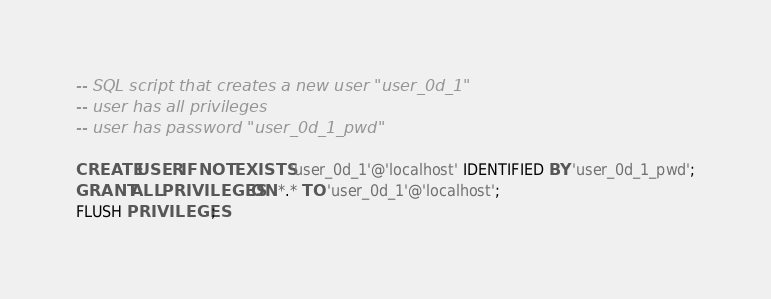<code> <loc_0><loc_0><loc_500><loc_500><_SQL_>-- SQL script that creates a new user "user_0d_1"
-- user has all privileges
-- user has password "user_0d_1_pwd"

CREATE USER IF NOT EXISTS 'user_0d_1'@'localhost' IDENTIFIED BY 'user_0d_1_pwd';
GRANT ALL PRIVILEGES ON *.* TO 'user_0d_1'@'localhost';
FLUSH PRIVILEGES;
</code> 